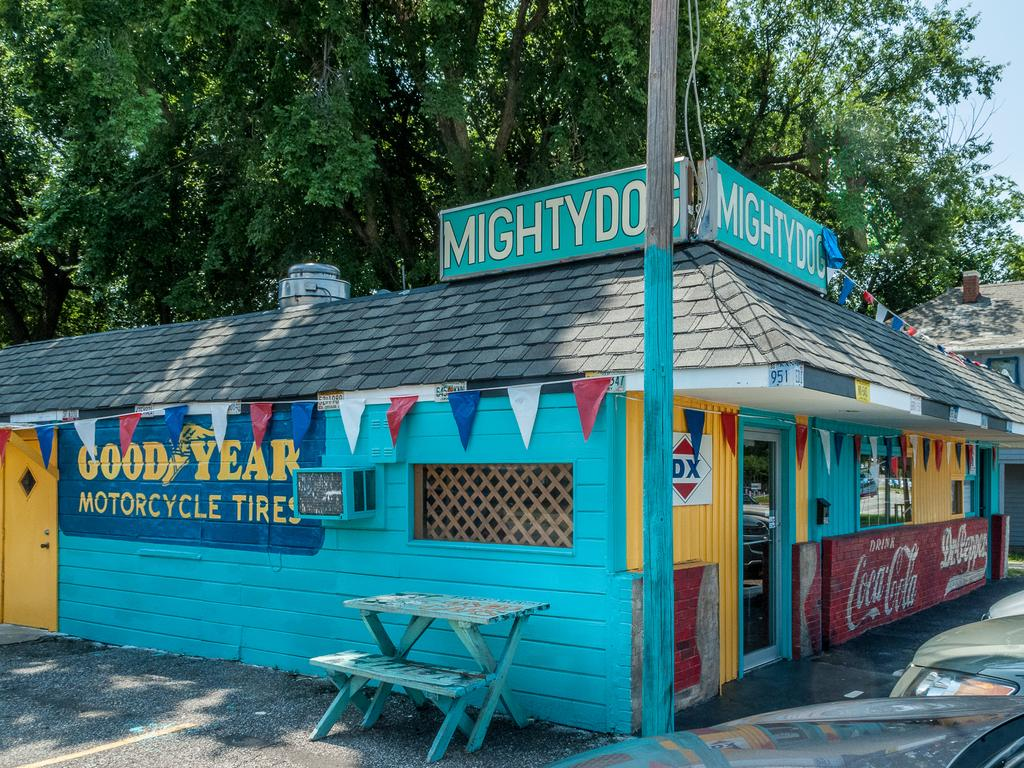What type of structure is visible in the picture? There is a house in the picture. What other natural element can be seen in the picture? There is a tree in the picture. What type of respect can be seen in the picture? There is no indication of respect in the picture, as it only features a house and a tree. How many pets are visible in the picture? There are no pets visible in the picture; it only features a house and a tree. 